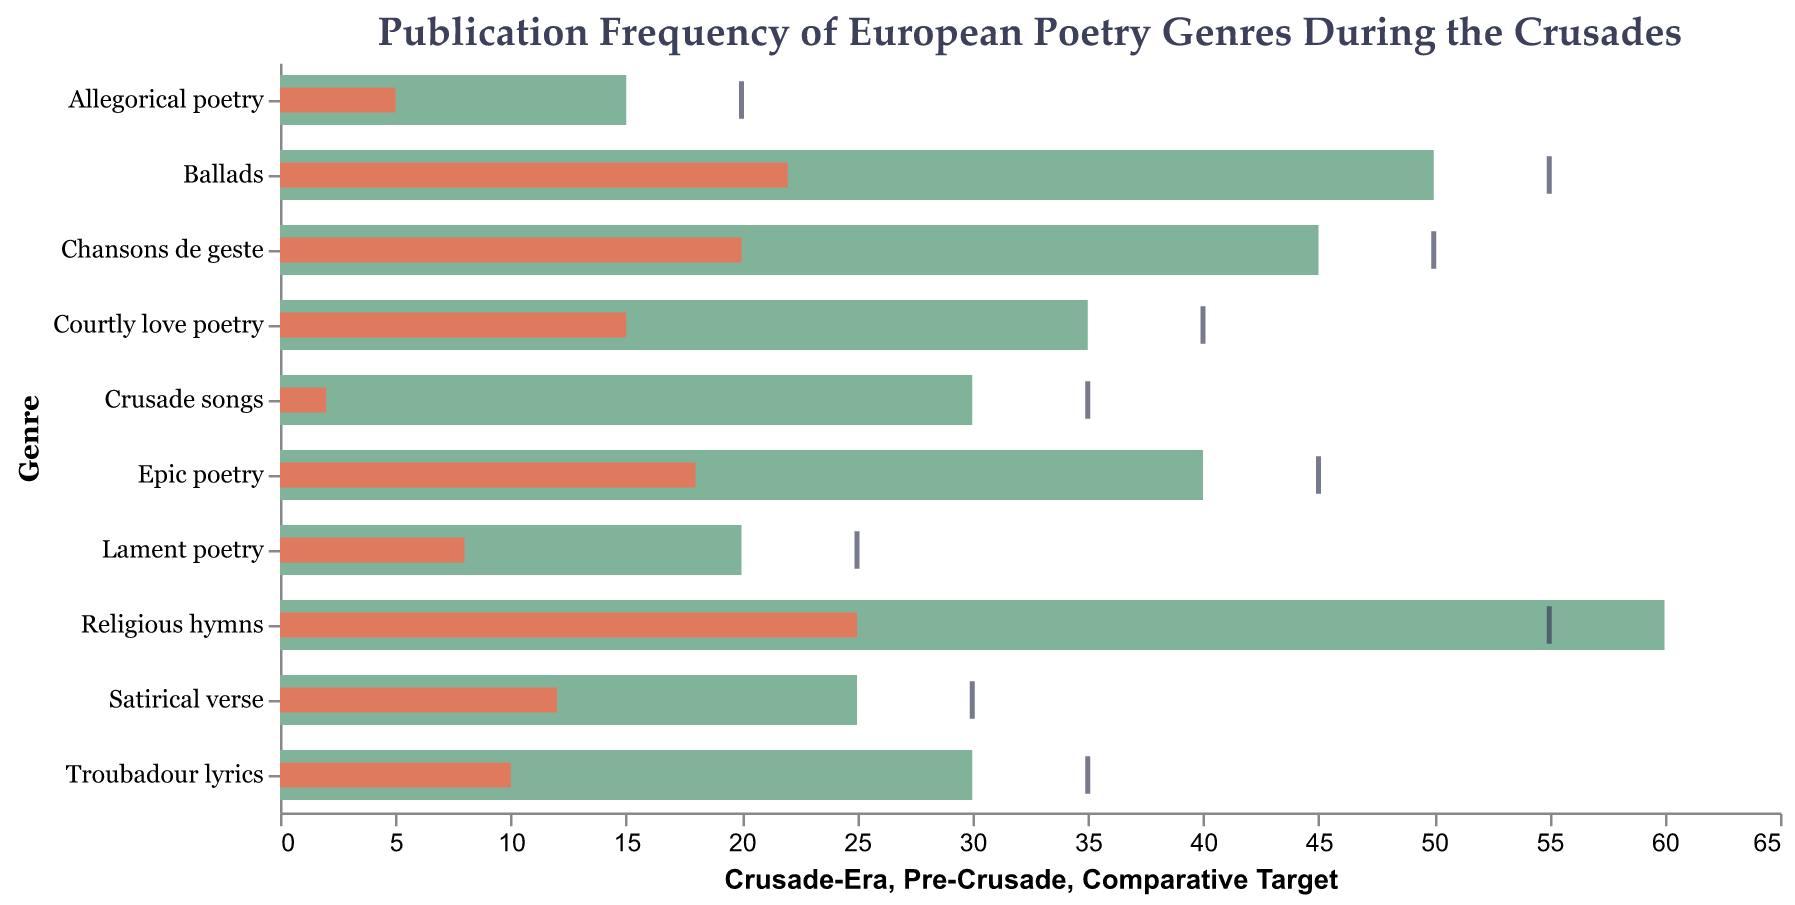What is the title of the chart? The title is located at the top of the chart and is usually descriptive of the data being presented. The title of this chart is "Publication Frequency of European Poetry Genres During the Crusades."
Answer: Publication Frequency of European Poetry Genres During the Crusades Which genre saw the highest frequency during the Crusade era? To determine which genre had the highest frequency, look at the lengths of the bars representing "Crusade-Era" frequencies. The longest bar corresponds to "Religious hymns" with a frequency of 60.
Answer: Religious hymns How many genres have a Crusade-Era frequency of 30 or more? Count the number of bars representing "Crusade-Era" frequencies that are equal to or greater than 30. These genres are "Chansons de geste," "Courtly love poetry," "Religious hymns," "Troubadour lyrics," "Epic poetry," "Ballads," and "Crusade songs." This totals to 7 genres.
Answer: 7 Which genre has the smallest increase in publication frequency from the Pre-Crusade to Crusade-Era? To find the smallest increase, subtract each genre's "Pre-Crusade" frequency from its "Crusade-Era" frequency and find the smallest difference. "Lament poetry" increased by 12 (20-8), which is the smallest.
Answer: Lament poetry What is the average Crusade-Era frequency for all poetry genres? Add all the "Crusade-Era" frequencies and divide by the number of genres (10). The sum is 45 + 35 + 60 + 30 + 40 + 25 + 20 + 15 + 50 + 30 = 350. Dividing by 10 gives an average of 35.
Answer: 35 Which genre is closest to its Comparative Target? Calculate the absolute difference between each genre's "Crusade-Era" frequency and its "Comparative Target." The genre with the smallest difference is "Religious hymns" (60-55 = 5).
Answer: Religious hymns How much did the publication frequency of "Ballads" increase from Pre-Crusade to Crusade-Era? Subtract the Pre-Crusade frequency of "Ballads" from its Crusade-Era frequency (50 - 22). This gives an increase of 28.
Answer: 28 Which genres have a Crusade-Era frequency lower than their Comparative Targets? Identify genres where the "Crusade-Era" frequency is less than the "Comparative Target." These genres are "Chansons de geste," "Courtly love poetry," "Troubadour lyrics," "Epic poetry," "Satirical verse," "Lament poetry," "Allegorical poetry," "Ballads," and "Crusade songs."
Answer: 9 genres By how much did "Crusade songs" increase in publication frequency? Subtract the Pre-Crusade frequency from the Crusade-Era frequency for "Crusade songs" (30 - 2). This gives an increase of 28.
Answer: 28 What trend can be observed in the publication of religious-themed poetry during the Crusades compared to the Pre-Crusade era? Compare the "Religious hymns" and "Lament poetry" frequencies before and during the Crusades. Both genres show significant increases: "Religious hymns" from 25 to 60, and "Lament poetry" from 8 to 20. This indicates a trend of increased publication in religious-themed poetry.
Answer: Increased religious-themed poetry 